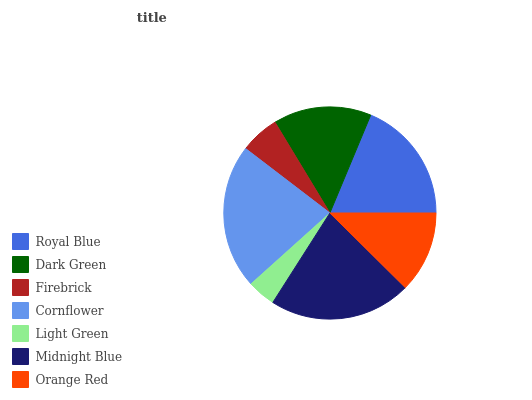Is Light Green the minimum?
Answer yes or no. Yes. Is Cornflower the maximum?
Answer yes or no. Yes. Is Dark Green the minimum?
Answer yes or no. No. Is Dark Green the maximum?
Answer yes or no. No. Is Royal Blue greater than Dark Green?
Answer yes or no. Yes. Is Dark Green less than Royal Blue?
Answer yes or no. Yes. Is Dark Green greater than Royal Blue?
Answer yes or no. No. Is Royal Blue less than Dark Green?
Answer yes or no. No. Is Dark Green the high median?
Answer yes or no. Yes. Is Dark Green the low median?
Answer yes or no. Yes. Is Royal Blue the high median?
Answer yes or no. No. Is Midnight Blue the low median?
Answer yes or no. No. 